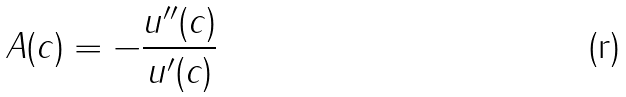<formula> <loc_0><loc_0><loc_500><loc_500>A ( c ) = - \frac { u ^ { \prime \prime } ( c ) } { u ^ { \prime } ( c ) }</formula> 